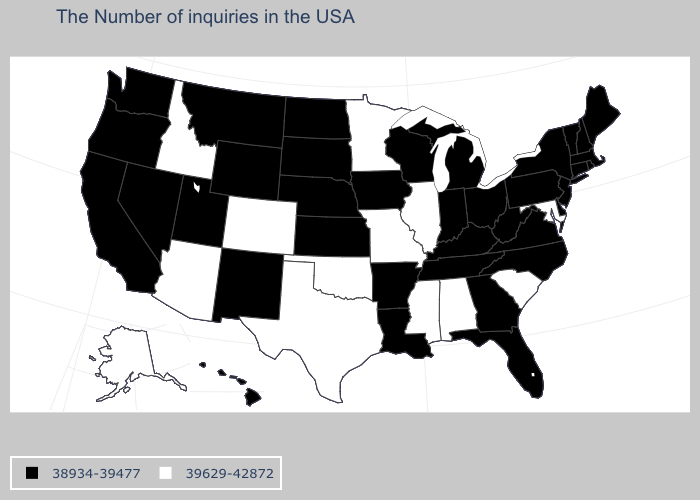What is the value of New York?
Be succinct. 38934-39477. Which states have the highest value in the USA?
Quick response, please. Maryland, South Carolina, Alabama, Illinois, Mississippi, Missouri, Minnesota, Oklahoma, Texas, Colorado, Arizona, Idaho, Alaska. What is the value of Rhode Island?
Quick response, please. 38934-39477. What is the value of New Mexico?
Quick response, please. 38934-39477. What is the value of Massachusetts?
Answer briefly. 38934-39477. Does the first symbol in the legend represent the smallest category?
Write a very short answer. Yes. What is the value of Louisiana?
Answer briefly. 38934-39477. Does Montana have the highest value in the West?
Write a very short answer. No. Does Ohio have the lowest value in the USA?
Give a very brief answer. Yes. Does Arizona have the lowest value in the USA?
Concise answer only. No. Name the states that have a value in the range 38934-39477?
Concise answer only. Maine, Massachusetts, Rhode Island, New Hampshire, Vermont, Connecticut, New York, New Jersey, Delaware, Pennsylvania, Virginia, North Carolina, West Virginia, Ohio, Florida, Georgia, Michigan, Kentucky, Indiana, Tennessee, Wisconsin, Louisiana, Arkansas, Iowa, Kansas, Nebraska, South Dakota, North Dakota, Wyoming, New Mexico, Utah, Montana, Nevada, California, Washington, Oregon, Hawaii. Does the first symbol in the legend represent the smallest category?
Keep it brief. Yes. Does the first symbol in the legend represent the smallest category?
Answer briefly. Yes. What is the lowest value in the USA?
Write a very short answer. 38934-39477. Name the states that have a value in the range 39629-42872?
Concise answer only. Maryland, South Carolina, Alabama, Illinois, Mississippi, Missouri, Minnesota, Oklahoma, Texas, Colorado, Arizona, Idaho, Alaska. 